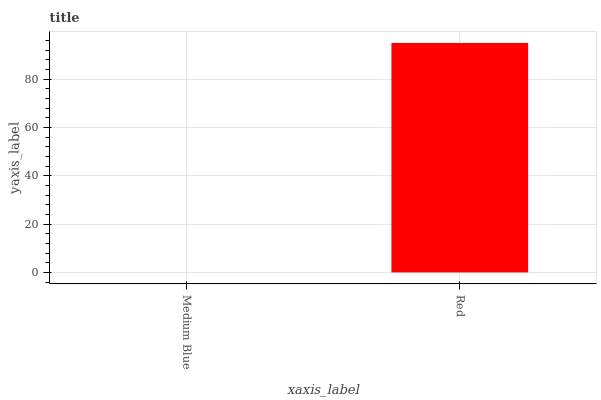Is Medium Blue the minimum?
Answer yes or no. Yes. Is Red the maximum?
Answer yes or no. Yes. Is Red the minimum?
Answer yes or no. No. Is Red greater than Medium Blue?
Answer yes or no. Yes. Is Medium Blue less than Red?
Answer yes or no. Yes. Is Medium Blue greater than Red?
Answer yes or no. No. Is Red less than Medium Blue?
Answer yes or no. No. Is Red the high median?
Answer yes or no. Yes. Is Medium Blue the low median?
Answer yes or no. Yes. Is Medium Blue the high median?
Answer yes or no. No. Is Red the low median?
Answer yes or no. No. 